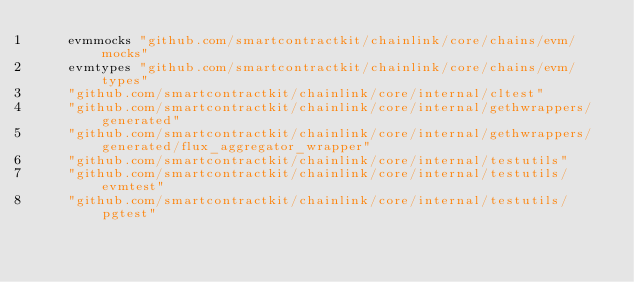Convert code to text. <code><loc_0><loc_0><loc_500><loc_500><_Go_>	evmmocks "github.com/smartcontractkit/chainlink/core/chains/evm/mocks"
	evmtypes "github.com/smartcontractkit/chainlink/core/chains/evm/types"
	"github.com/smartcontractkit/chainlink/core/internal/cltest"
	"github.com/smartcontractkit/chainlink/core/internal/gethwrappers/generated"
	"github.com/smartcontractkit/chainlink/core/internal/gethwrappers/generated/flux_aggregator_wrapper"
	"github.com/smartcontractkit/chainlink/core/internal/testutils"
	"github.com/smartcontractkit/chainlink/core/internal/testutils/evmtest"
	"github.com/smartcontractkit/chainlink/core/internal/testutils/pgtest"</code> 